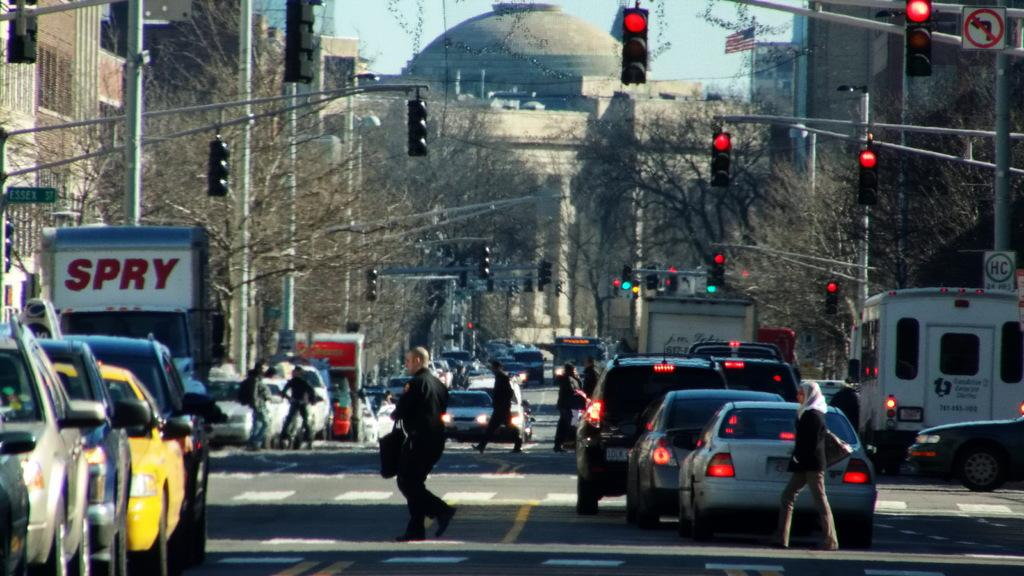<image>
Relay a brief, clear account of the picture shown. A white SPRY truck sits at a busy stoplight with other cars. 